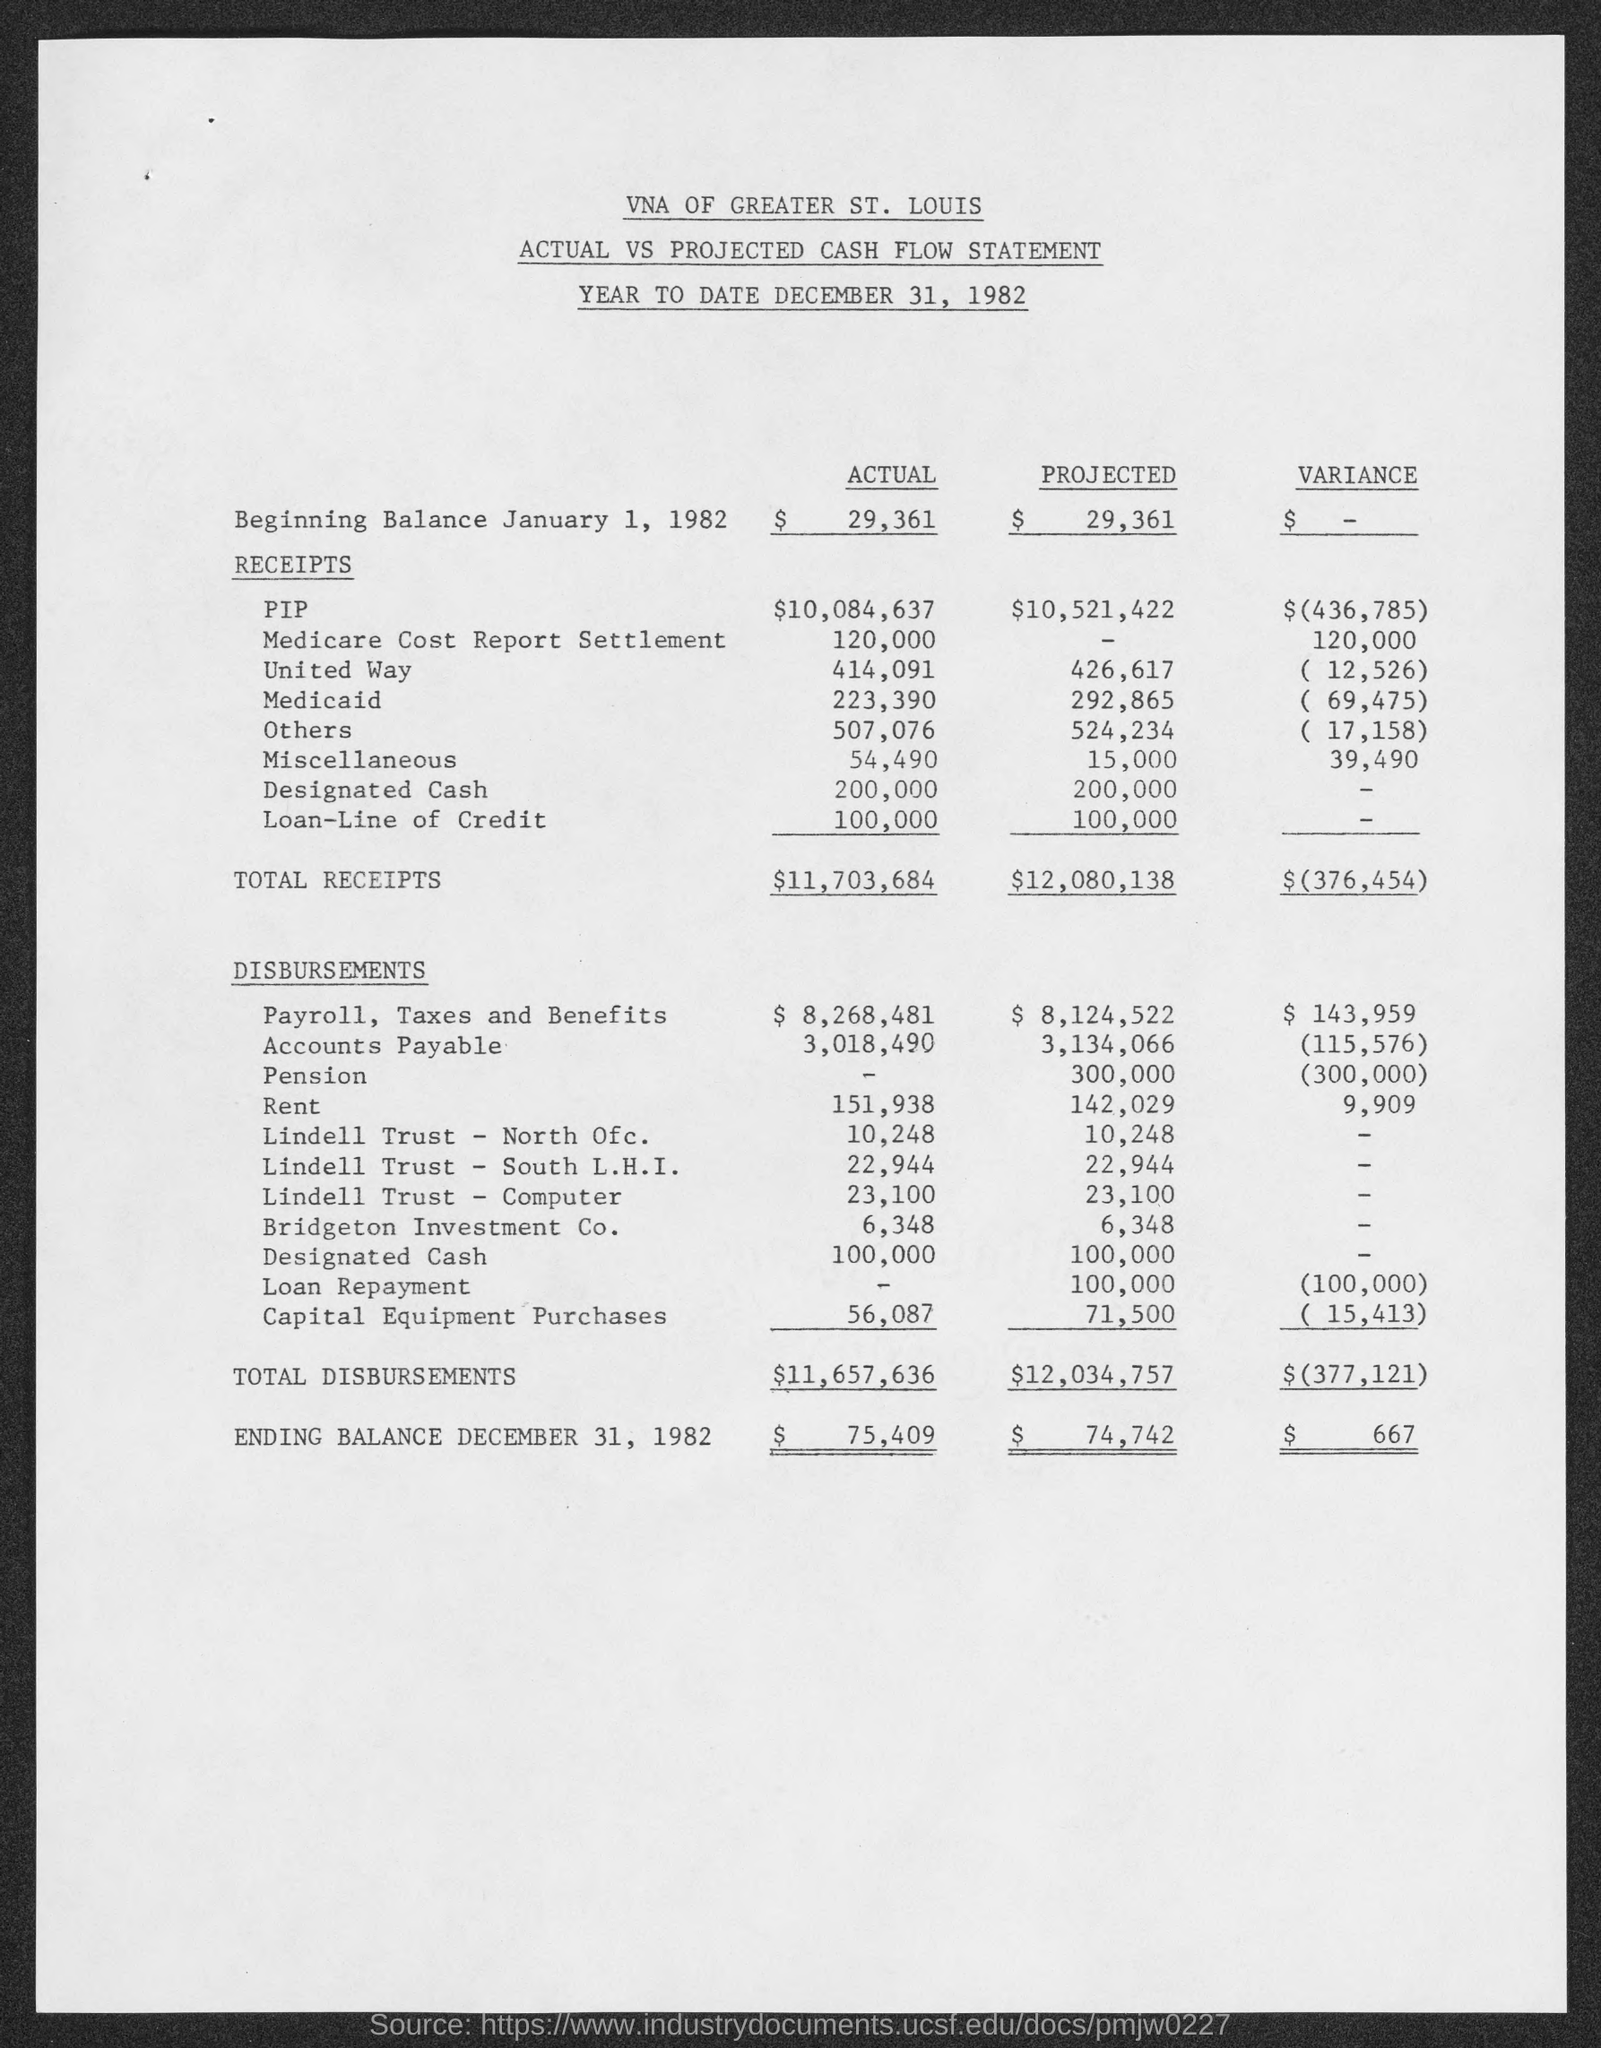Specify some key components in this picture. The total disbursements of the projected amount is $12,034,757. The ending balance of actual as of December 31, 1982 was $75,409. The total disbursements of actual amounted to $11,657,636. The total receipts for the current situation are $11,703,684. The total disbursements of variance is $(377,121).. 